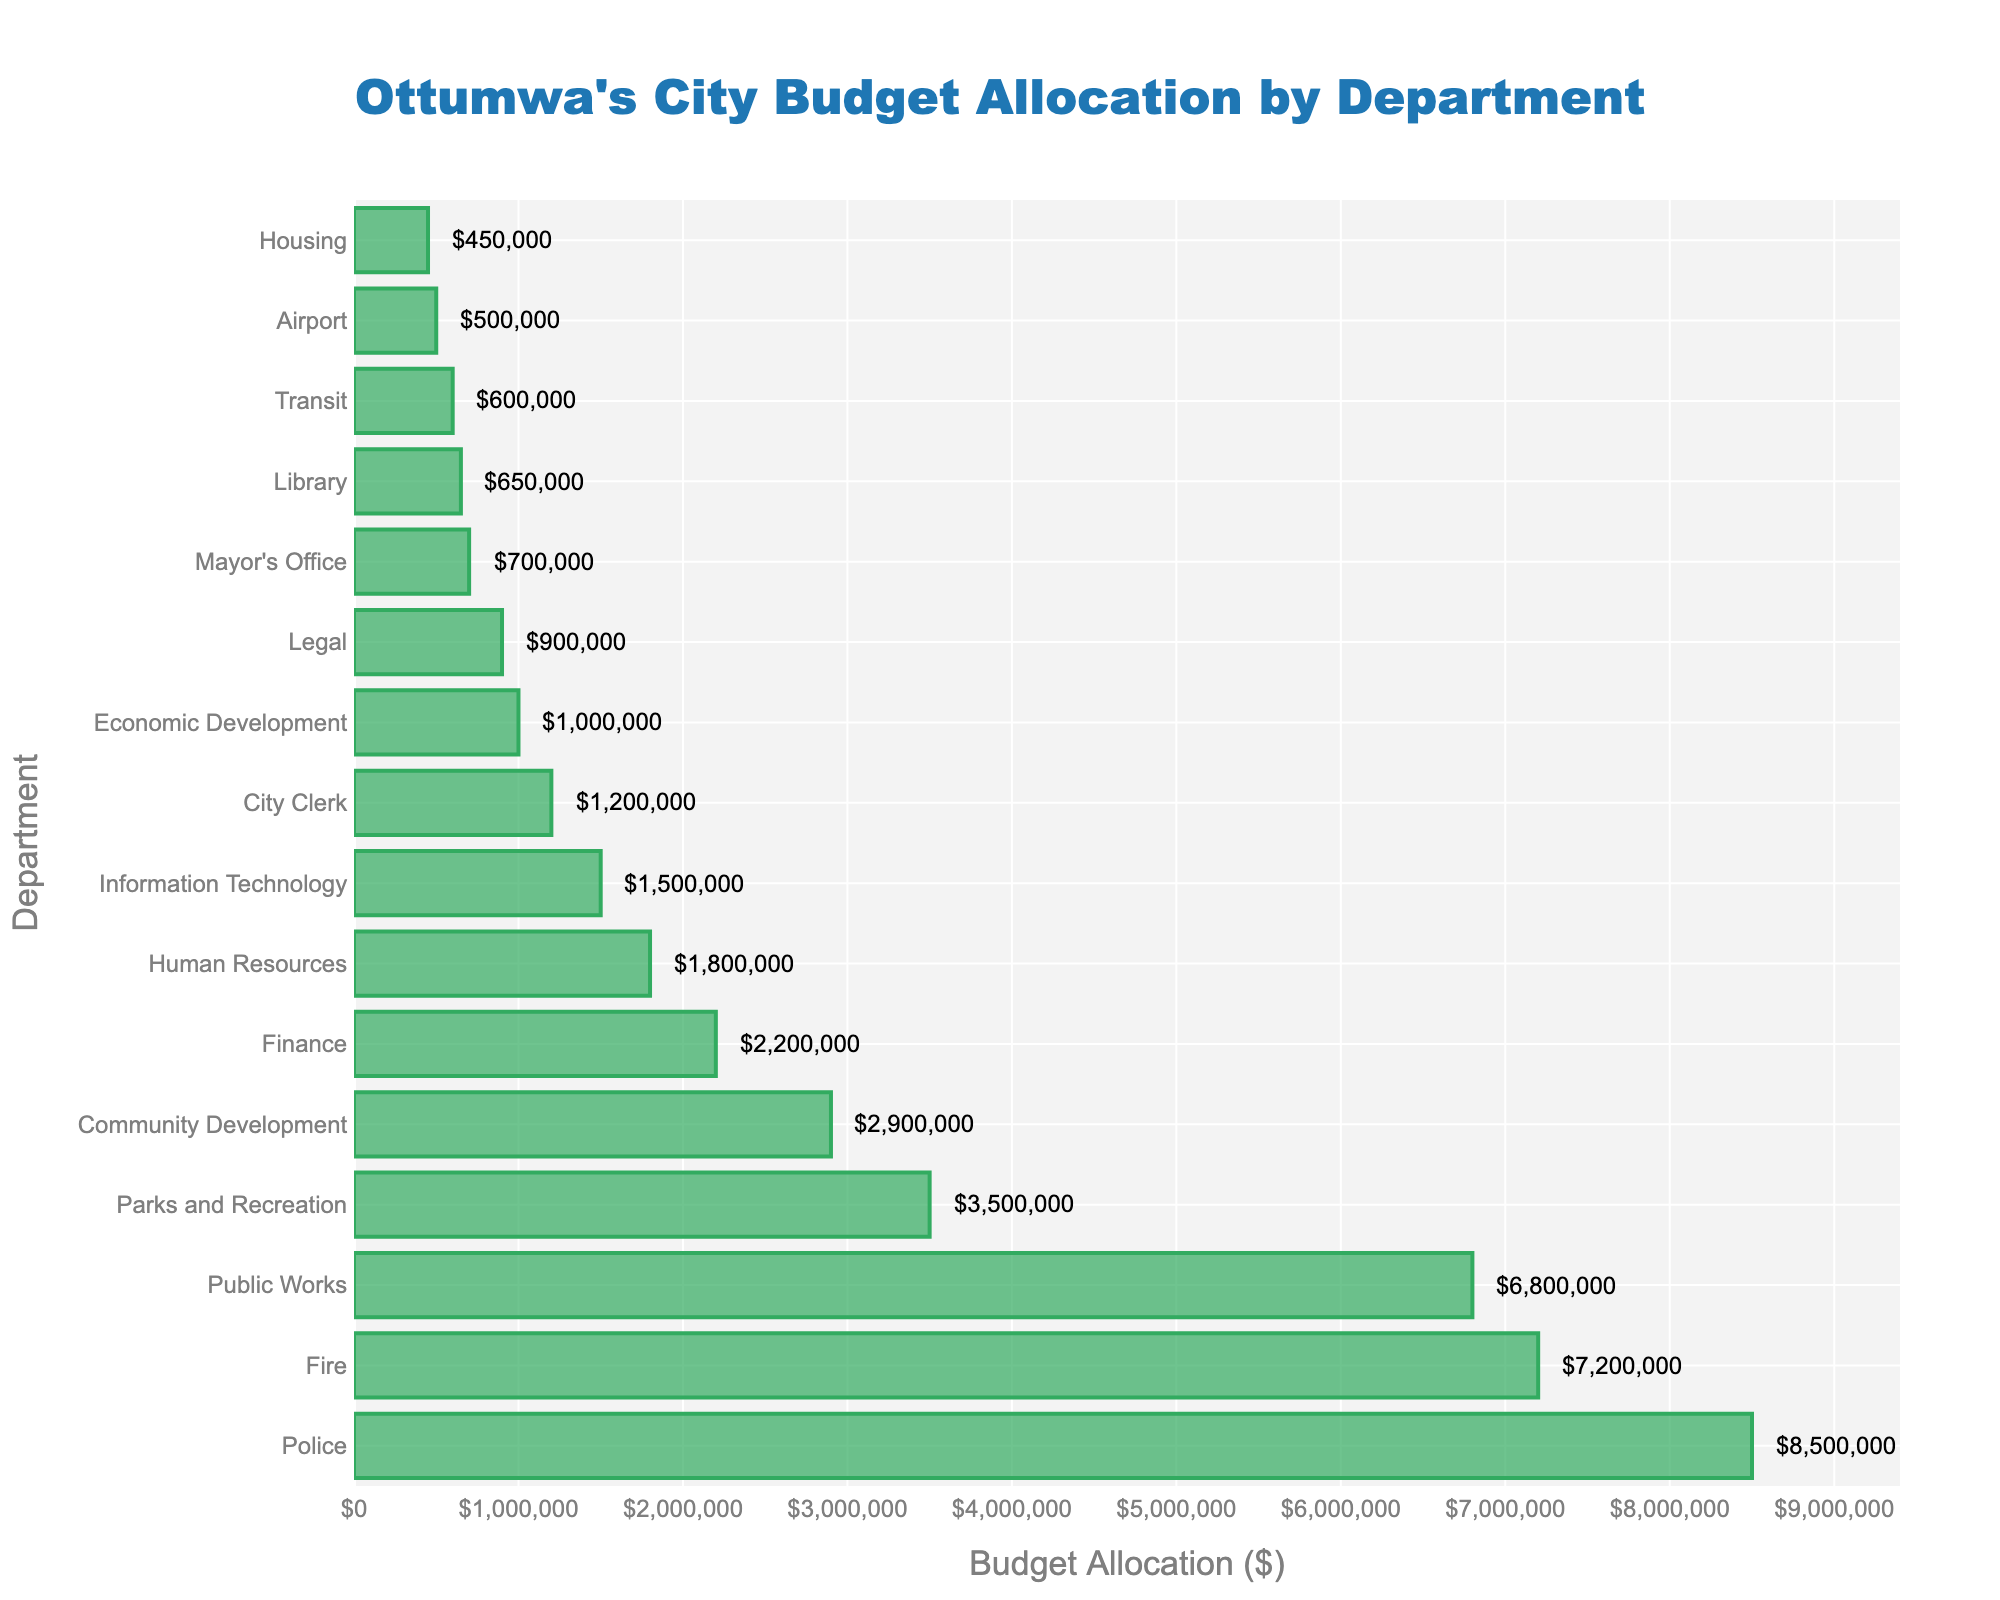Which department has the highest budget allocation? The department with the highest budget allocation is identified by finding the bar with the greatest length on the chart. The Police department has the longest bar, indicating the highest budget allocation.
Answer: Police What is the combined budget allocation for the Fire and Public Works departments? To find the combined budget allocation, add the amounts for the Fire department ($7,200,000) and the Public Works department ($6,800,000). The sum is $7,200,000 + $6,800,000 = $14,000,000.
Answer: $14,000,000 Which department has the lowest budget allocation? The department with the lowest budget allocation is identified by finding the bar with the shortest length on the chart. The Housing department has the shortest bar, indicating the lowest budget allocation.
Answer: Housing How much more is allocated to the Police department compared to the Fire department? To find the difference, subtract the Fire department's budget allocation ($7,200,000) from the Police department's budget allocation ($8,500,000). The difference is $8,500,000 - $7,200,000 = $1,300,000.
Answer: $1,300,000 Which departments have a budget allocation greater than $5,000,000? Departments with a budget allocation greater than $5,000,000 have bars extending past the $5,000,000 mark. These are the Police, Fire, and Public Works departments.
Answer: Police, Fire, Public Works What is the total budget allocation for departments whose allocation exceeds $1,000,000 but is less than $2,000,000? Identify and sum the allocations for departments within the range. Human Resources ($1,800,000), Information Technology ($1,500,000), and City Clerk ($1,200,000) fall in this range. The total is $1,800,000 + $1,500,000 + $1,200,000 = $4,500,000.
Answer: $4,500,000 How much is the budget allocation for Parks and Recreation compared to Community Development? Compare the budget allocations by observing the length of the respective bars. Parks and Recreation has an allocation of $3,500,000, and Community Development has an allocation of $2,900,000.
Answer: $3,500,000 vs. $2,900,000 Are there more departments with a budget allocation below or above $1,000,000? Count the number of departments with allocations below and above $1,000,000. There are 3 departments below ($1,000,000) and 13 departments above ($1,000,000).
Answer: Above What is the average budget allocation for the Legal, Mayor's Office, and Library departments? Sum the budget allocations for Legal ($900,000), Mayor's Office ($700,000), and Library ($650,000), then divide by the number of departments. The total is $900,000 + $700,000 + $650,000 = $2,250,000. The average is $2,250,000 ÷ 3 = $750,000.
Answer: $750,000 